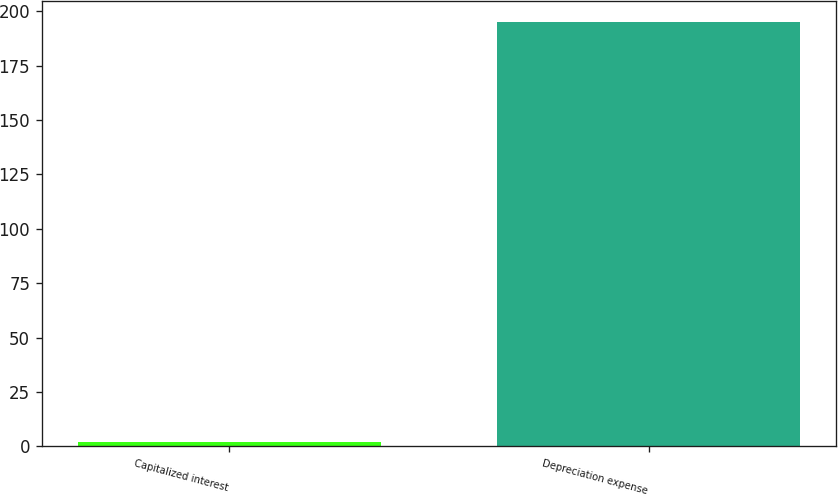Convert chart. <chart><loc_0><loc_0><loc_500><loc_500><bar_chart><fcel>Capitalized interest<fcel>Depreciation expense<nl><fcel>2<fcel>195<nl></chart> 